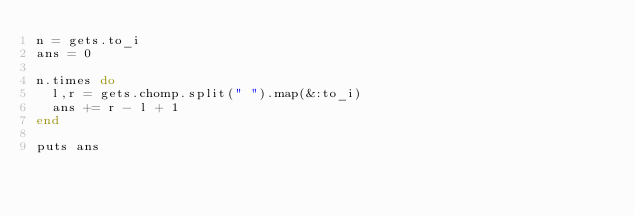<code> <loc_0><loc_0><loc_500><loc_500><_Ruby_>n = gets.to_i
ans = 0

n.times do 
  l,r = gets.chomp.split(" ").map(&:to_i)
  ans += r - l + 1
end

puts ans</code> 